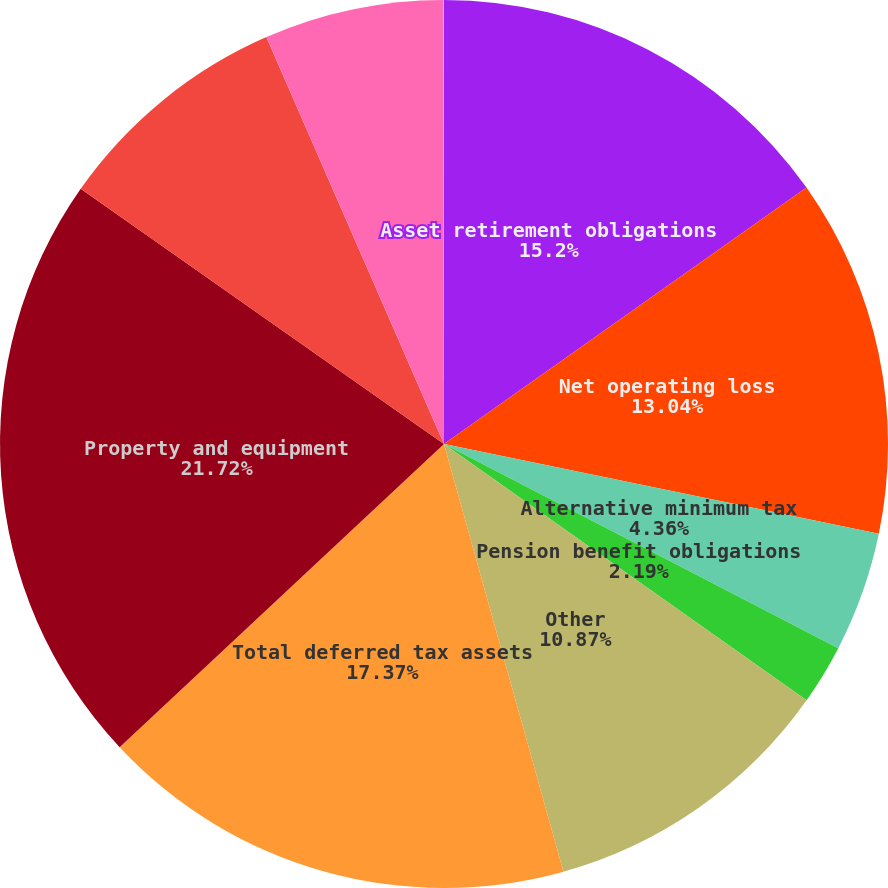<chart> <loc_0><loc_0><loc_500><loc_500><pie_chart><fcel>Asset retirement obligations<fcel>Net operating loss<fcel>Alternative minimum tax<fcel>Pension benefit obligations<fcel>Other<fcel>Total deferred tax assets<fcel>Property and equipment<fcel>Long-term debt<fcel>Taxes on unremitted foreign<fcel>Fair value of financial<nl><fcel>15.2%<fcel>13.04%<fcel>4.36%<fcel>2.19%<fcel>10.87%<fcel>17.37%<fcel>21.71%<fcel>8.7%<fcel>6.53%<fcel>0.02%<nl></chart> 